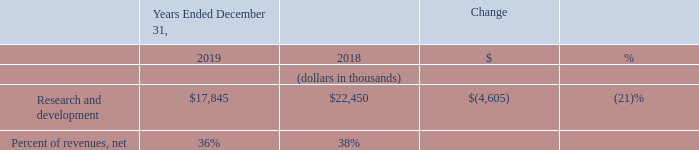Research and Development
Research and development expenses in 2019 decreased by $4.6 million, or 21%, as compared to 2018. The decrease was primarily due to a reduction in the number of full-time research and development personnel, resulting in a decrease of $3.1 million in compensation expense and $0.6 million in allocated facilities and information technology costs as compared to 2018. We did not incur restructuring costs in 2019, as compared to 2018 when $0.1 million was incurred as part of the 2018 Restructuring Plan (refer to Note 4 of the accompanying consolidated financial statements). Finally, the decrease was further driven by lower professional fees of $0.6 million, as we reduced the number of research and development contractors as compared to 2018.
What is the decrease in research and development expenses in 2019? $4.6 million. What led to the decrease in research and development expenses in 2019? Reduction in the number of full-time research and development personnel. What are the respective values of research and development expenses in 2018 and 2019?
Answer scale should be: thousand. $22,450, $17,845. What is the total research and development expenses in 2018 and 2019?
Answer scale should be: thousand. 22,450 + 17,845 
Answer: 40295. What is the average research and development expense in 2018 and 2019?
Answer scale should be: thousand. (22,450 + 17,845)/2 
Answer: 20147.5. What is the value of the change in research and development expenses as a percentage of the company's 2018 expenses?
Answer scale should be: percent. 4,605/22,450 
Answer: 20.51. 